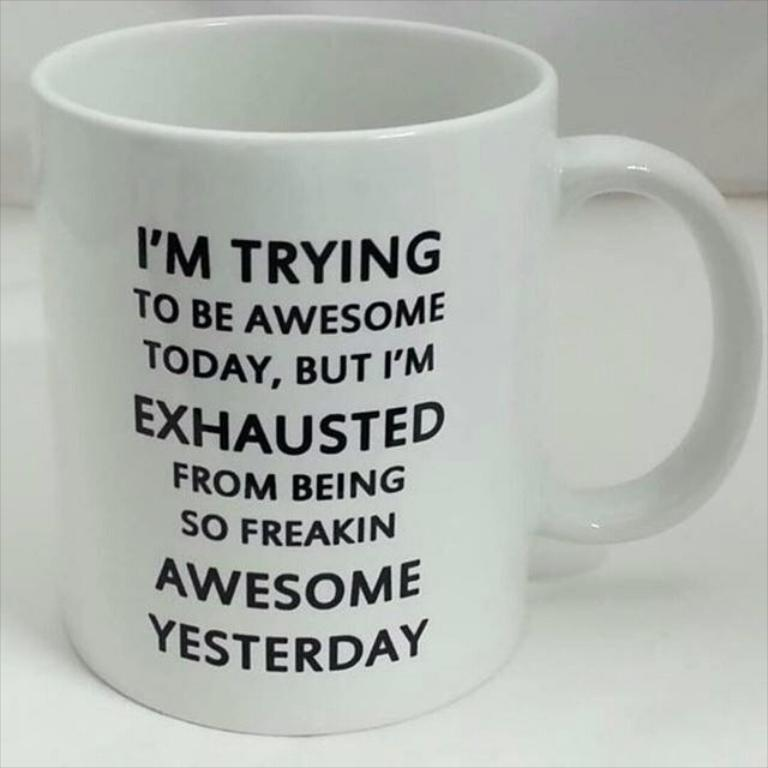<image>
Present a compact description of the photo's key features. The object is a large coffee mug with a funny saying written in black and all caps. 